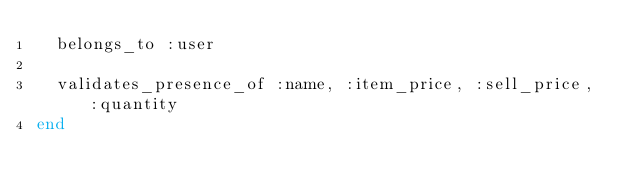Convert code to text. <code><loc_0><loc_0><loc_500><loc_500><_Ruby_>  belongs_to :user

  validates_presence_of :name, :item_price, :sell_price, :quantity
end
</code> 